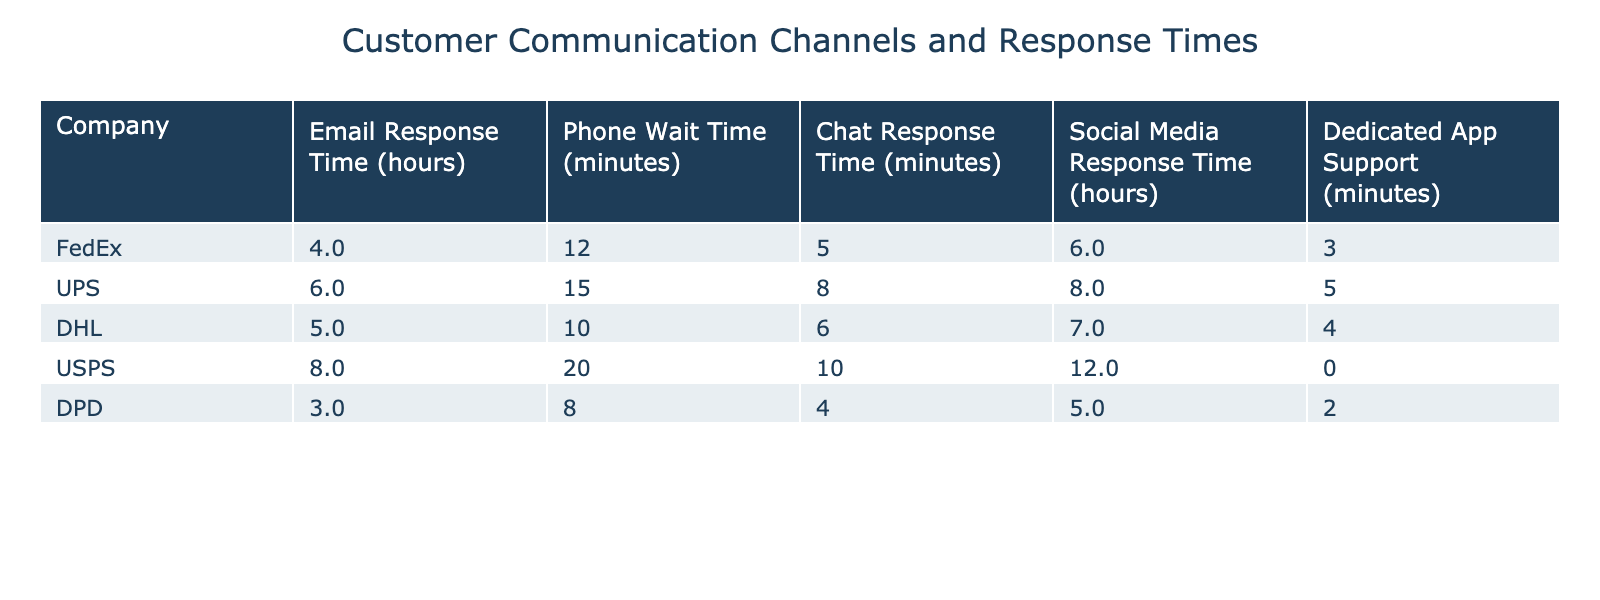What is the email response time for UPS? The table shows the email response time for UPS as 6 hours.
Answer: 6 hours Which company has the shortest phone wait time? Looking at the phone wait times, DPD has the shortest wait time of 8 minutes.
Answer: DPD What is the average chat response time for all companies? The chat response times are 5, 8, 6, 10, and 4 minutes. When summed (5 + 8 + 6 + 10 + 4 = 33) and divided by 5, the average is 33 / 5 = 6.6 minutes.
Answer: 6.6 minutes Is USPS's social media response time higher than FedEx's? USPS has a social media response time of 12 hours, while FedEx has 6 hours. Since 12 is greater than 6, the statement is true.
Answer: Yes What is the difference in email response times between DPD and DHL? DPD's email response time is 3 hours, and DHL's is 5 hours. The difference is 5 - 3 = 2 hours.
Answer: 2 hours Which company provides dedicated app support, and what is the response time? The table shows that DPD provides dedicated app support with a response time of 2 minutes.
Answer: DPD, 2 minutes Which company has the highest overall response times (considering all channels)? By comparing the response times (email, phone, chat, social media, and app), calculate the total for each company. For USPS: 8 + 20 + 10 + 12 + N/A = 50 (excluding app support as it is not applicable). For UPS: 6 + 15 + 8 + 8 + 5 = 42, and similar for others. USPS has the highest overall time.
Answer: USPS How much faster is DPD in chat response time compared to USPS? DPD has a chat response time of 4 minutes, while USPS has 10 minutes. The difference is 10 - 4 = 6 minutes, indicating DPD is faster.
Answer: 6 minutes Are the social media response times for FedEx and DHL the same? FedEx's social media response time is 6 hours, while DHL's is 7 hours. Since these values are different, the answer is no.
Answer: No What is the total wait time when combining the phone wait times of UPS, DHL, and DPD? The phone wait times for these companies are 15 minutes (UPS), 10 minutes (DHL), and 8 minutes (DPD). Adding them together (15 + 10 + 8) gives a total of 33 minutes.
Answer: 33 minutes 